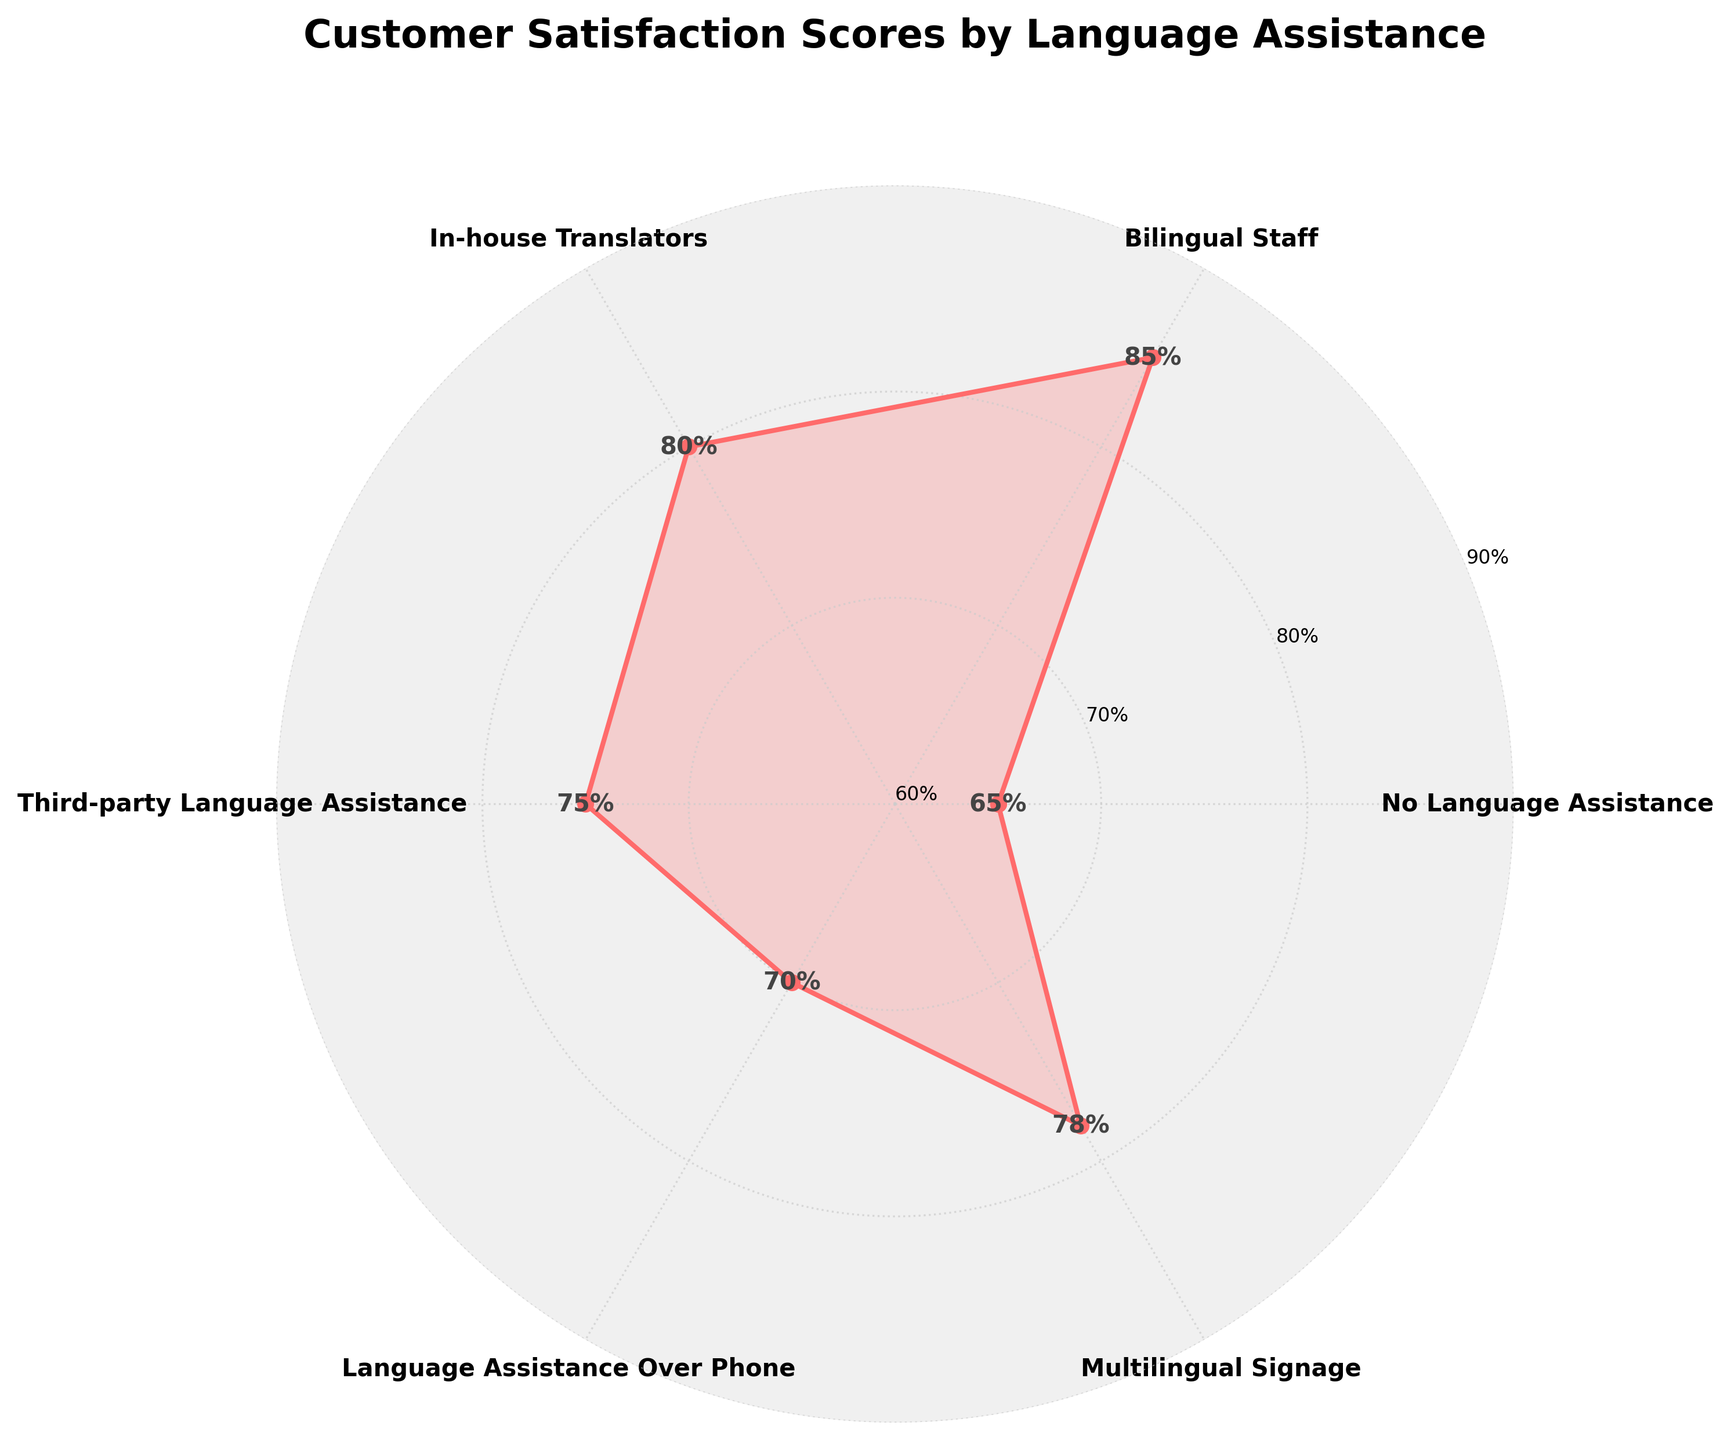What does the title of the rose chart indicate? The title indicates the content and purpose of the chart, which is to show customer satisfaction scores based on the availability of different types of language assistance.
Answer: Customer Satisfaction Scores by Language Assistance How many different types of language assistance are shown in the rose chart? By counting the unique labels around the chart, there are six different types of language assistance displayed.
Answer: Six What is the highest customer satisfaction score shown in the rose chart? By observing the outermost point on the chart, the highest score can be identified. It is the point with the value labeled 85%.
Answer: 85% Which type of language assistance corresponds to the highest customer satisfaction score? By matching the highest score of 85% with its corresponding label, the type of assistance is found. The label at this point is "Bilingual Staff."
Answer: Bilingual Staff What is the average customer satisfaction score of all the language assistance types? First, sum up all the scores: 65 + 85 + 80 + 75 + 70 + 78 = 453. Then, divide by the number of types, which is 6. The computation is 453 / 6.
Answer: 75.5 Which language assistance type has a satisfaction score closest to the average score of all types? The average score is 75.5. By checking the scores: 65, 85, 80, 75, 70, 78, the closest to 75.5 is 75, which corresponds to "Third-party Language Assistance."
Answer: Third-party Language Assistance How many satisfaction scores are above 75%? By identifying the scores above 75% from the list: 85, 80, 78, there are three scores above 75%.
Answer: Three What is the difference in customer satisfaction score between "No Language Assistance" and "Bilingual Staff"? The satisfaction scores are 65 for "No Language Assistance" and 85 for "Bilingual Staff." Calculating the difference: 85 - 65.
Answer: 20 Which type of language assistance has the second highest customer satisfaction score? By arranging the scores in descending order: 85, 80, 78, 75, 70, 65, the second highest score is 80, which corresponds to "In-house Translators."
Answer: In-house Translators Is "Language Assistance Over Phone" more effective than "Multilingual Signage" in terms of customer satisfaction? By comparing their scores from the chart, 70 for "Language Assistance Over Phone" and 78 for "Multilingual Signage," 78 is higher than 70. Hence, "Multilingual Signage" is more effective.
Answer: No 